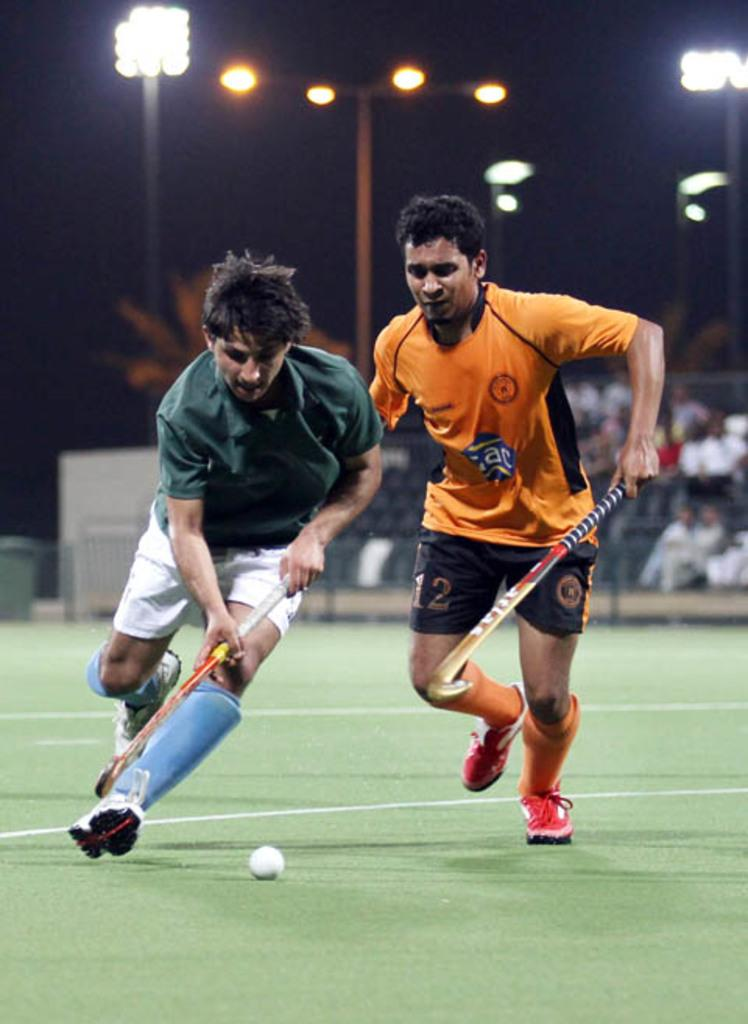<image>
Describe the image concisely. two people playing field hockey with one wearing the number 12 